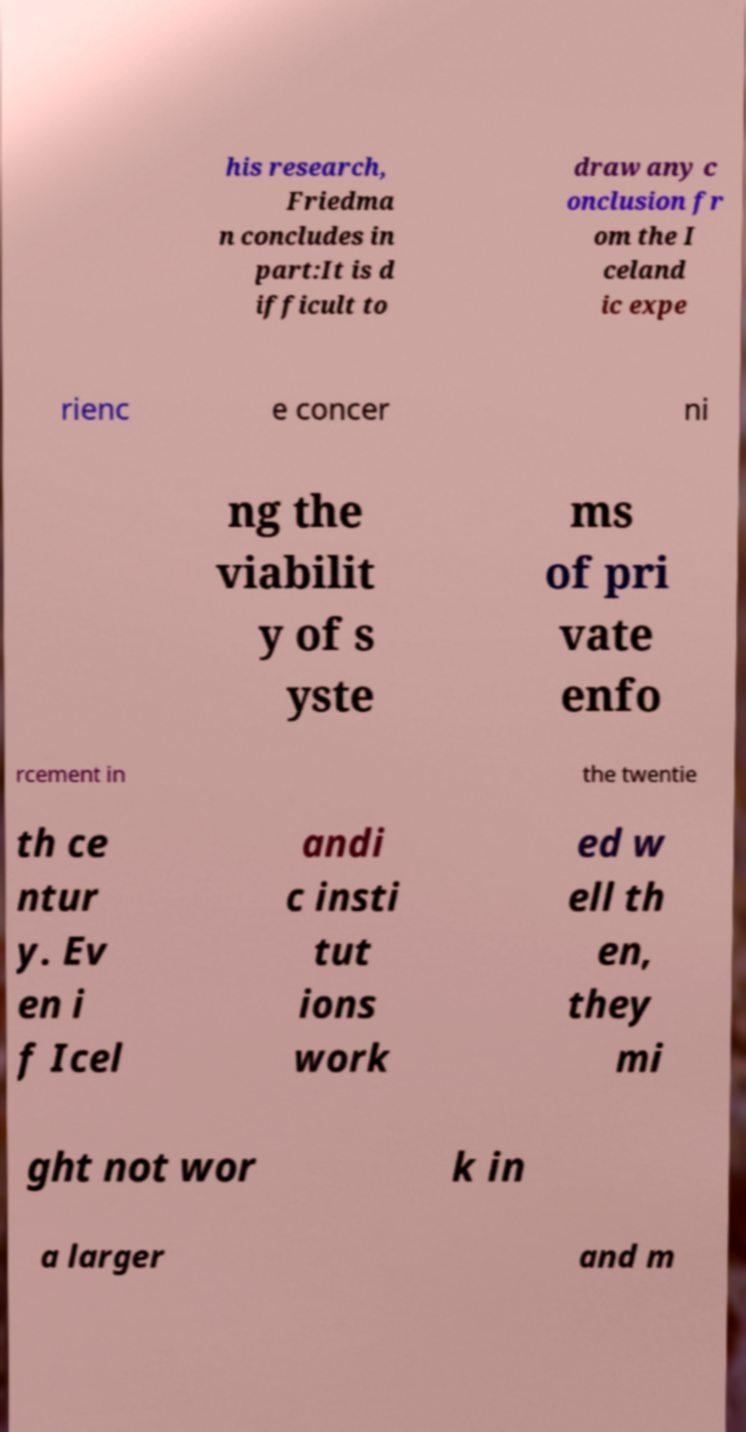Please identify and transcribe the text found in this image. his research, Friedma n concludes in part:It is d ifficult to draw any c onclusion fr om the I celand ic expe rienc e concer ni ng the viabilit y of s yste ms of pri vate enfo rcement in the twentie th ce ntur y. Ev en i f Icel andi c insti tut ions work ed w ell th en, they mi ght not wor k in a larger and m 